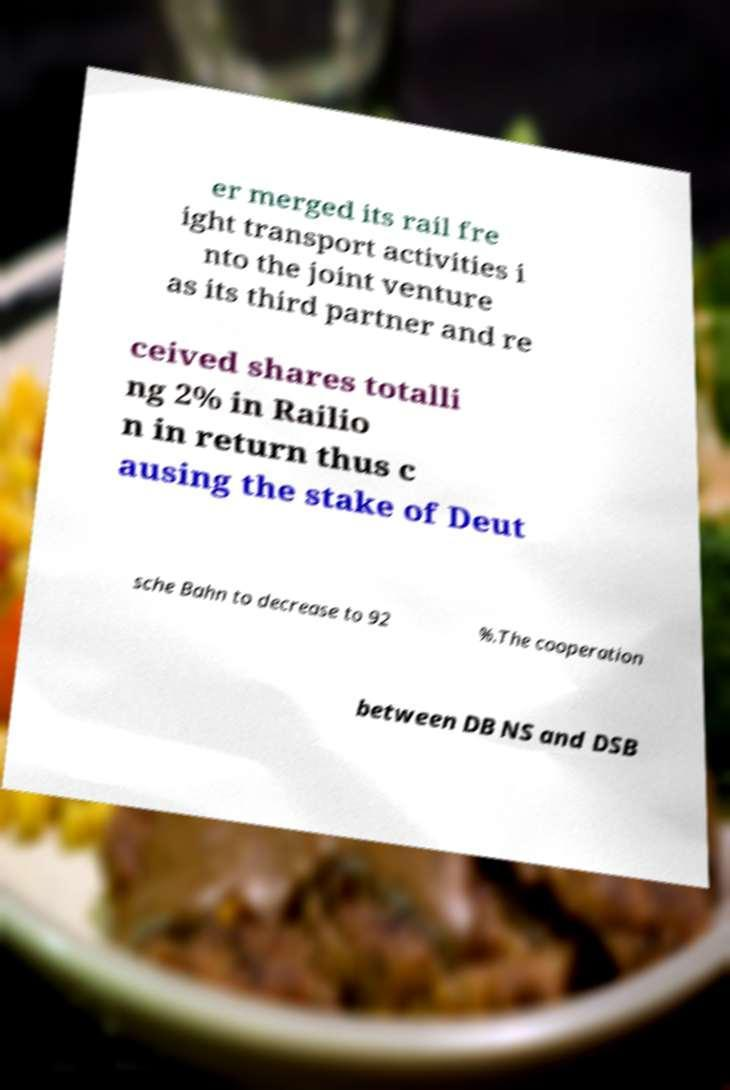Please identify and transcribe the text found in this image. er merged its rail fre ight transport activities i nto the joint venture as its third partner and re ceived shares totalli ng 2% in Railio n in return thus c ausing the stake of Deut sche Bahn to decrease to 92 %.The cooperation between DB NS and DSB 